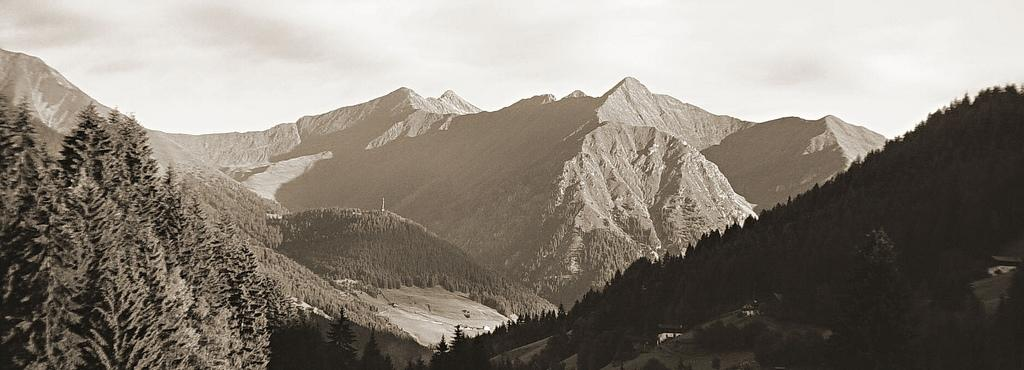What type of natural environment is depicted in the image? The image features many trees and mountains in the background. What can be seen in the sky in the image? The sky is visible in the background of the image. What type of polish is being applied to the trees in the image? There is no indication in the image that any polish is being applied to the trees; they appear to be natural. 